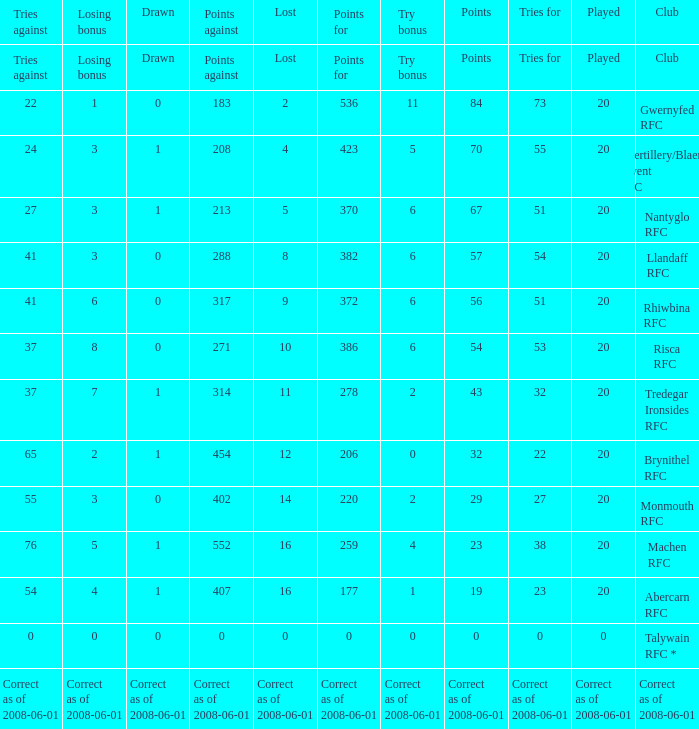Name the tries when tries against were 41, try bonus was 6, and had 317 points. 51.0. 